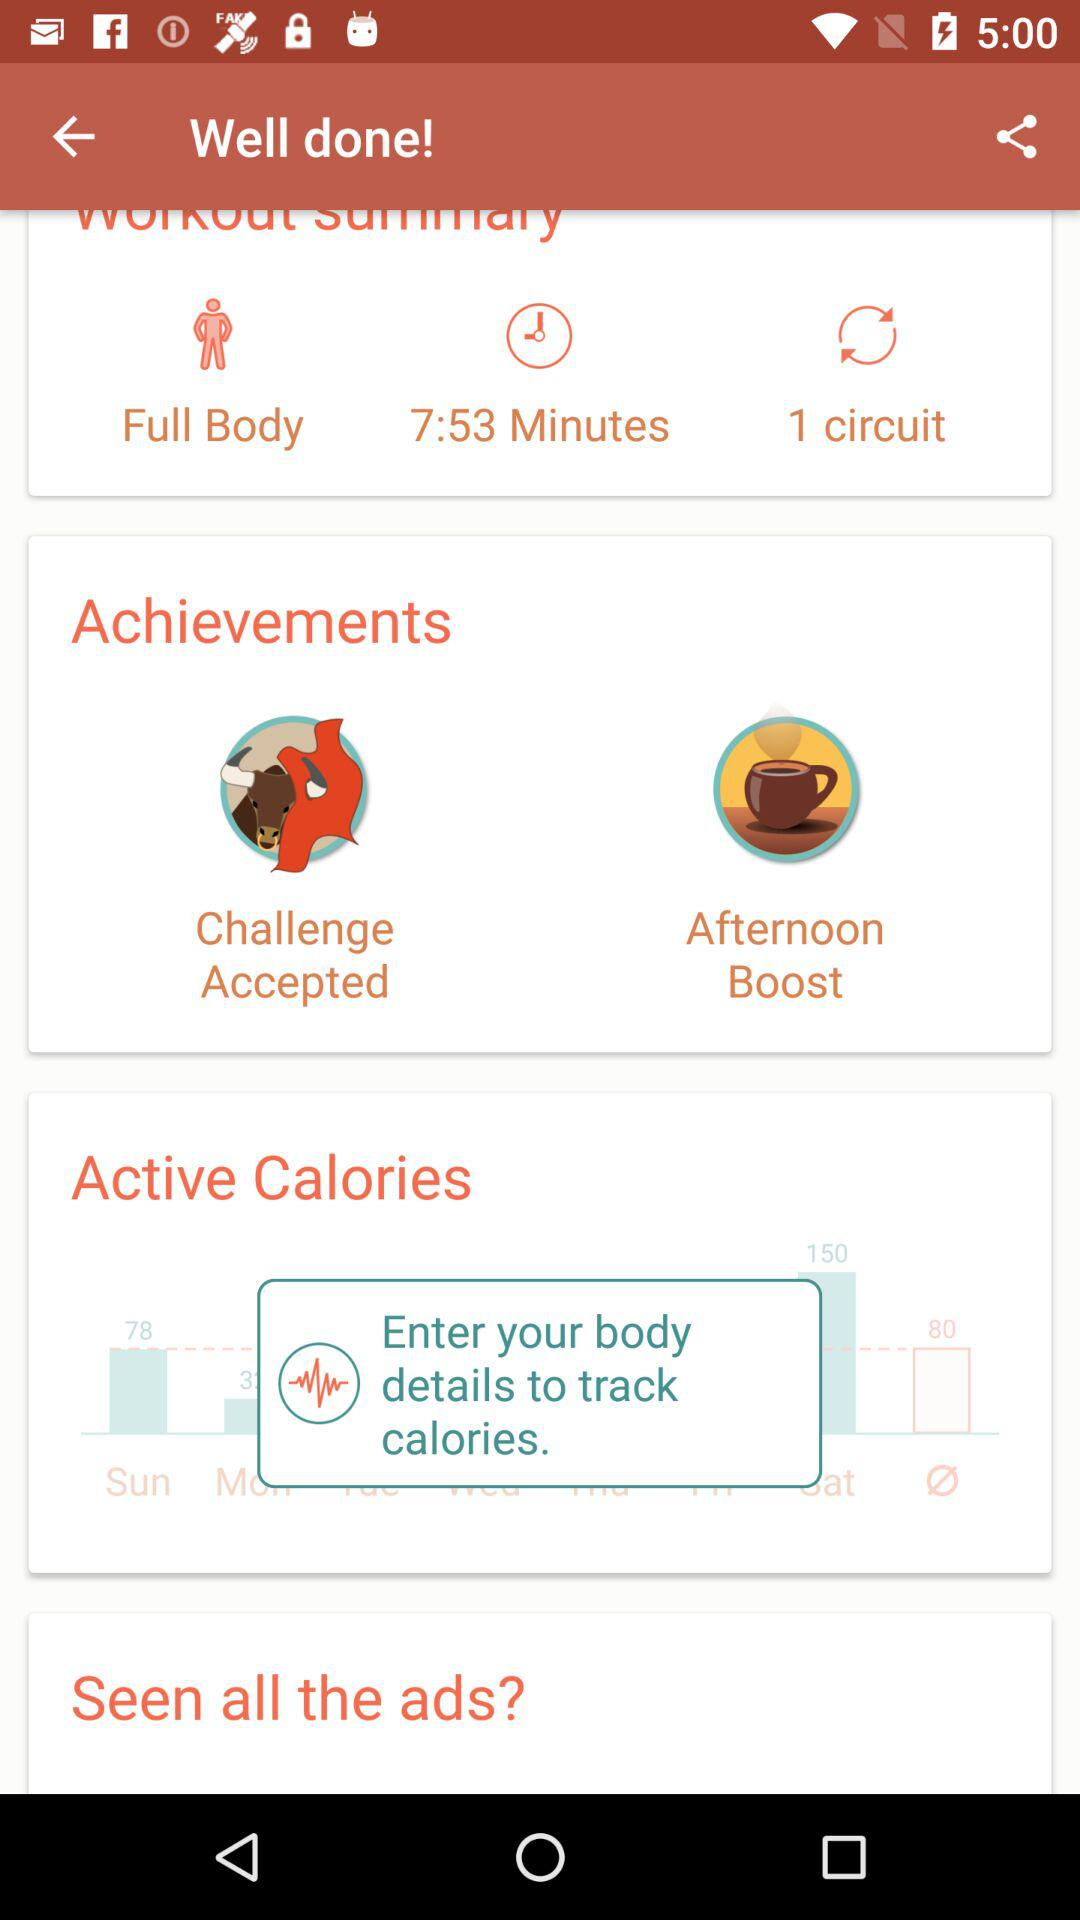What is the workout summary? The workout summary is "Full Body", "7:53 Minutes" and "1 circuit". 